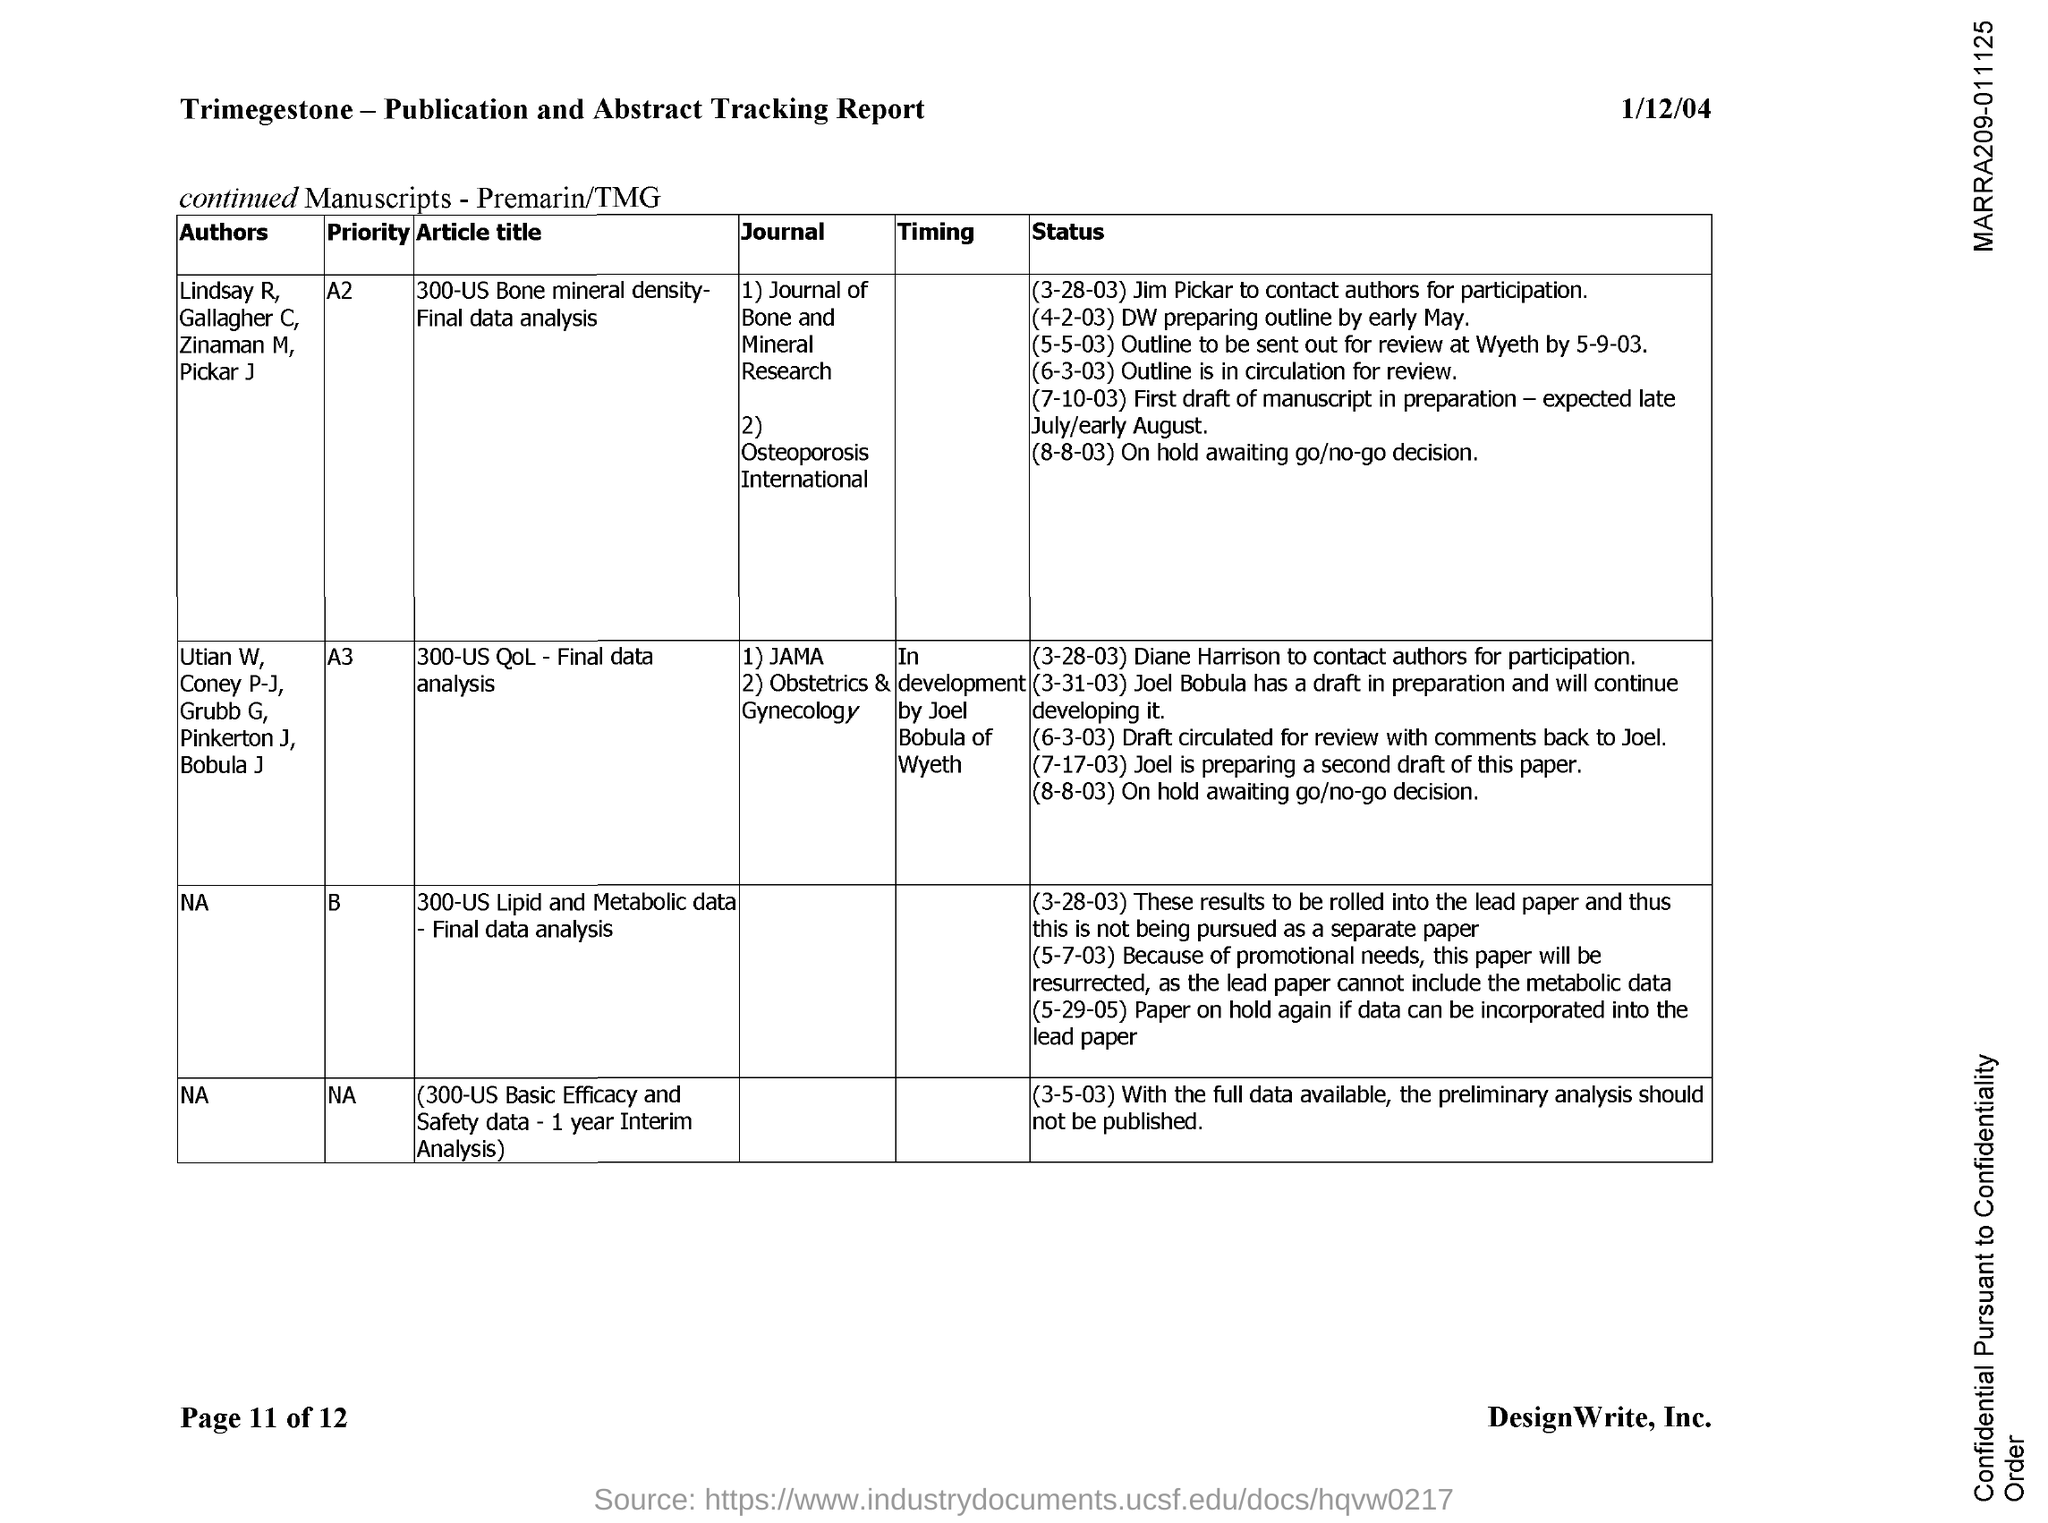Highlight a few significant elements in this photo. The page number mentioned in this document is 11 out of 12. The article titled "300-US QoL - Final data analysis" was authored by Utian W, Coney P-J, Grubb G, Pinkerton J, and Bobula J. The article titled "300-US Bone mineral density- Final data analysis" was written by the authors Lindsay R, Gallagher C, Zinaman M, and Pickar J. The date listed in the header of the document is January 12, 2004. 